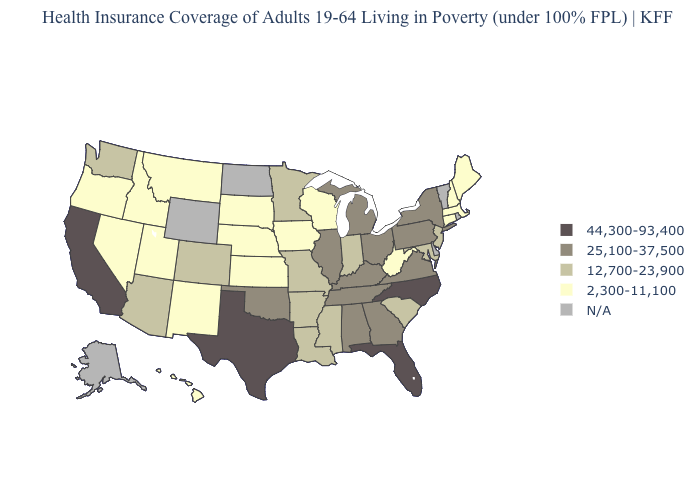Which states have the highest value in the USA?
Concise answer only. California, Florida, North Carolina, Texas. Which states have the lowest value in the MidWest?
Short answer required. Iowa, Kansas, Nebraska, South Dakota, Wisconsin. Which states have the lowest value in the Northeast?
Concise answer only. Connecticut, Maine, Massachusetts, New Hampshire. What is the value of Louisiana?
Concise answer only. 12,700-23,900. Does the map have missing data?
Be succinct. Yes. What is the value of Nebraska?
Be succinct. 2,300-11,100. What is the value of Oregon?
Write a very short answer. 2,300-11,100. What is the value of Mississippi?
Short answer required. 12,700-23,900. Name the states that have a value in the range 12,700-23,900?
Keep it brief. Arizona, Arkansas, Colorado, Indiana, Louisiana, Maryland, Minnesota, Mississippi, Missouri, New Jersey, South Carolina, Washington. What is the highest value in the USA?
Be succinct. 44,300-93,400. Does Texas have the highest value in the USA?
Concise answer only. Yes. Name the states that have a value in the range 25,100-37,500?
Quick response, please. Alabama, Georgia, Illinois, Kentucky, Michigan, New York, Ohio, Oklahoma, Pennsylvania, Tennessee, Virginia. Name the states that have a value in the range 2,300-11,100?
Give a very brief answer. Connecticut, Hawaii, Idaho, Iowa, Kansas, Maine, Massachusetts, Montana, Nebraska, Nevada, New Hampshire, New Mexico, Oregon, South Dakota, Utah, West Virginia, Wisconsin. 